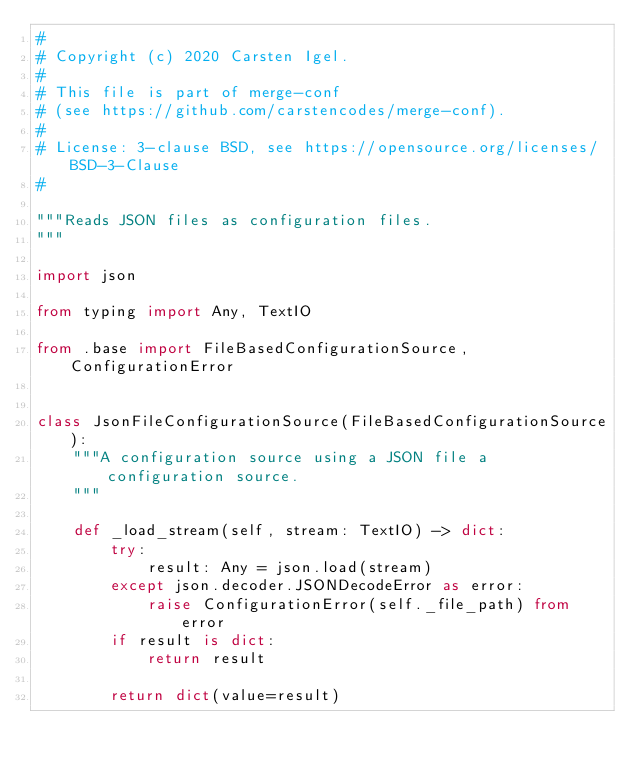Convert code to text. <code><loc_0><loc_0><loc_500><loc_500><_Python_>#
# Copyright (c) 2020 Carsten Igel.
#
# This file is part of merge-conf
# (see https://github.com/carstencodes/merge-conf).
#
# License: 3-clause BSD, see https://opensource.org/licenses/BSD-3-Clause
#

"""Reads JSON files as configuration files.
"""

import json

from typing import Any, TextIO

from .base import FileBasedConfigurationSource, ConfigurationError


class JsonFileConfigurationSource(FileBasedConfigurationSource):
    """A configuration source using a JSON file a configuration source.
    """

    def _load_stream(self, stream: TextIO) -> dict:
        try:
            result: Any = json.load(stream)
        except json.decoder.JSONDecodeError as error:
            raise ConfigurationError(self._file_path) from error
        if result is dict:
            return result

        return dict(value=result)
</code> 